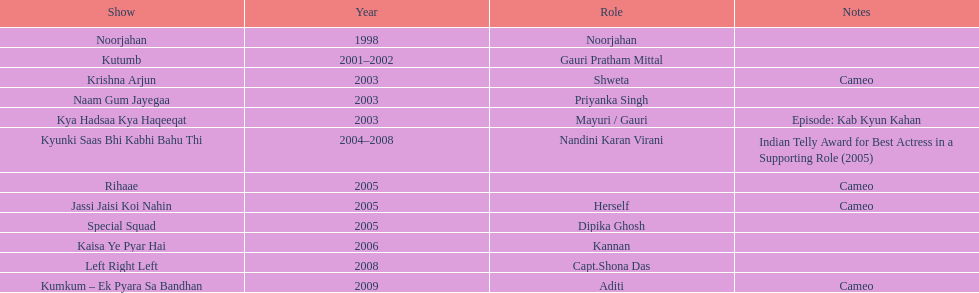What was the first tv series that gauri tejwani appeared in? Noorjahan. 